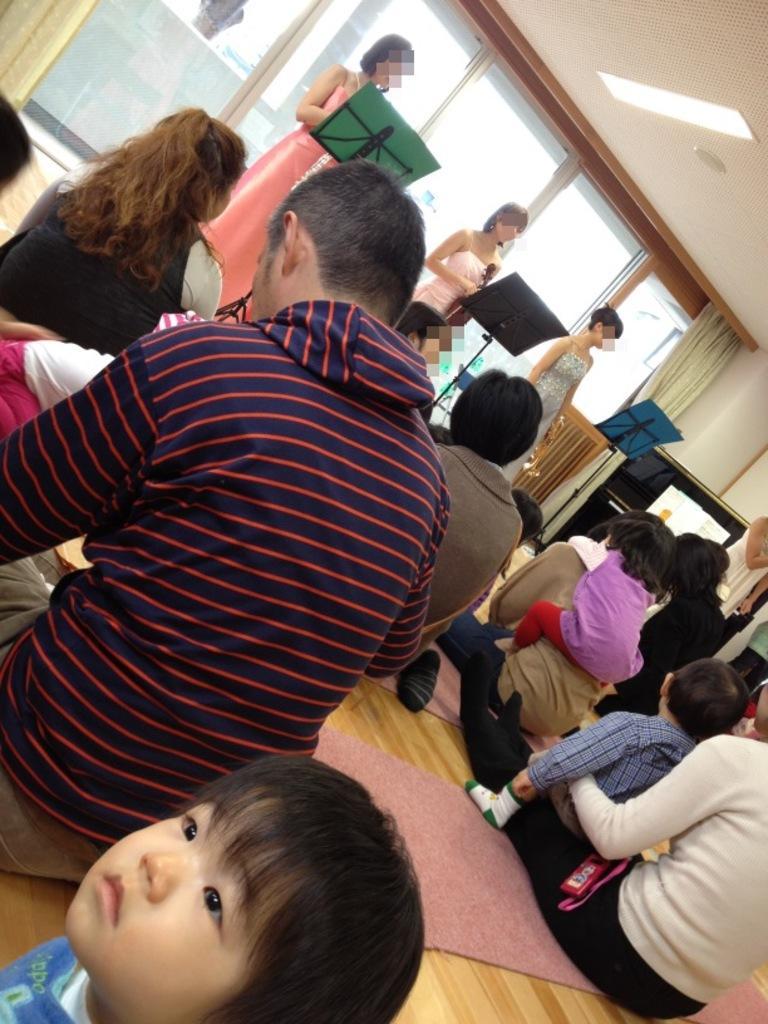Describe this image in one or two sentences. In the picture we can see some people are sitting on the wooden floor with their children and in front of them, we can see three women are standing and singing a song holding microphones and behind them, we can see a glass wall with curtains on the either sides and to the ceiling we can see the light. 